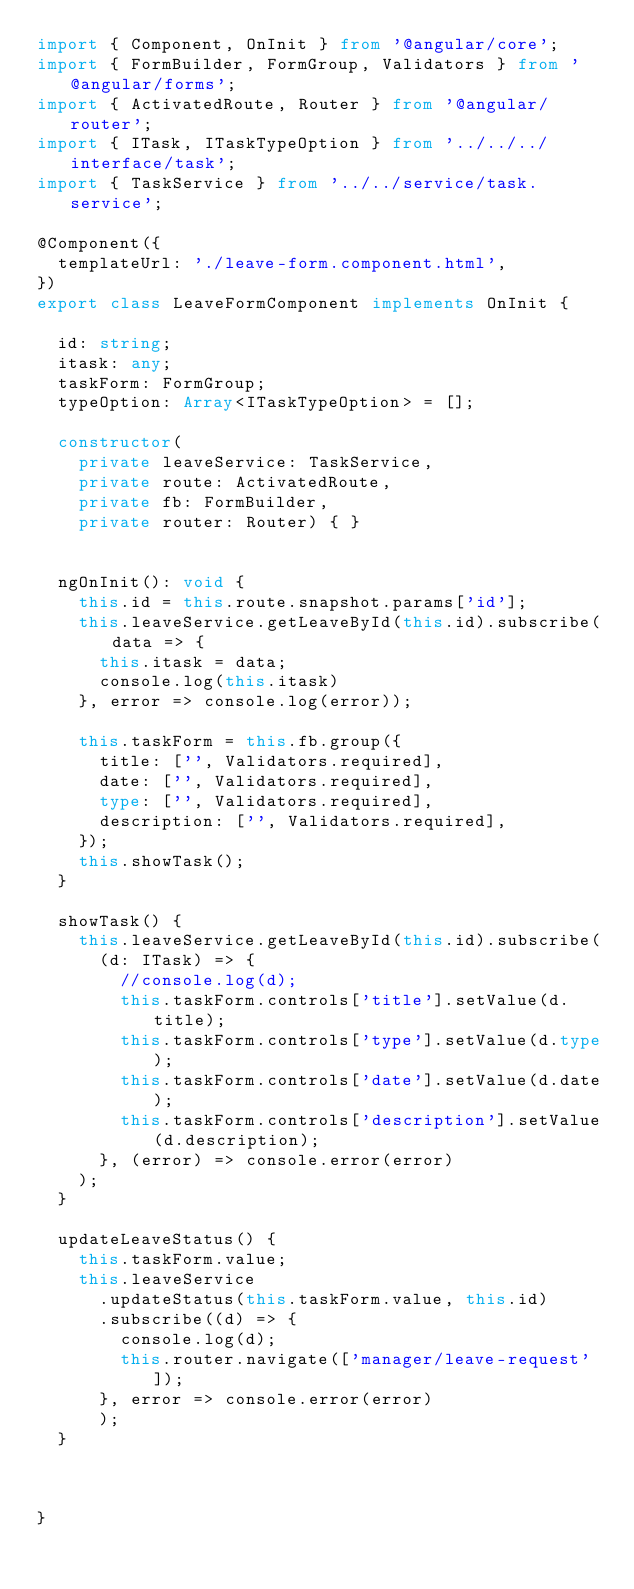Convert code to text. <code><loc_0><loc_0><loc_500><loc_500><_TypeScript_>import { Component, OnInit } from '@angular/core';
import { FormBuilder, FormGroup, Validators } from '@angular/forms';
import { ActivatedRoute, Router } from '@angular/router';
import { ITask, ITaskTypeOption } from '../../../interface/task';
import { TaskService } from '../../service/task.service';

@Component({
  templateUrl: './leave-form.component.html',
})
export class LeaveFormComponent implements OnInit {

  id: string;
  itask: any;
  taskForm: FormGroup;
  typeOption: Array<ITaskTypeOption> = [];

  constructor(
    private leaveService: TaskService,
    private route: ActivatedRoute,
    private fb: FormBuilder,
    private router: Router) { }


  ngOnInit(): void {
    this.id = this.route.snapshot.params['id'];
    this.leaveService.getLeaveById(this.id).subscribe(data => {
      this.itask = data;
      console.log(this.itask)
    }, error => console.log(error));

    this.taskForm = this.fb.group({
      title: ['', Validators.required],
      date: ['', Validators.required],
      type: ['', Validators.required],
      description: ['', Validators.required],
    });
    this.showTask();
  }

  showTask() {
    this.leaveService.getLeaveById(this.id).subscribe(
      (d: ITask) => {
        //console.log(d);
        this.taskForm.controls['title'].setValue(d.title);
        this.taskForm.controls['type'].setValue(d.type);
        this.taskForm.controls['date'].setValue(d.date);
        this.taskForm.controls['description'].setValue(d.description);
      }, (error) => console.error(error)
    );
  }

  updateLeaveStatus() {
    this.taskForm.value;
    this.leaveService
      .updateStatus(this.taskForm.value, this.id)
      .subscribe((d) => {
        console.log(d);
        this.router.navigate(['manager/leave-request']);
      }, error => console.error(error)
      );
  }



}
</code> 